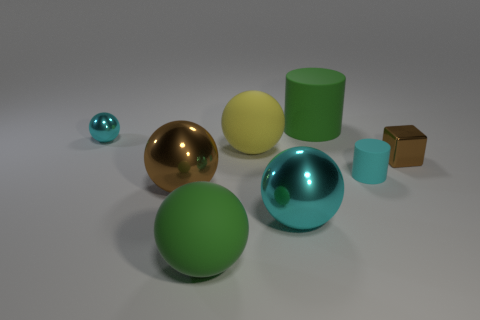Is the color of the tiny ball the same as the small cylinder?
Make the answer very short. Yes. What is the green thing left of the yellow object made of?
Offer a very short reply. Rubber. Are there any big rubber spheres of the same color as the large cylinder?
Provide a short and direct response. Yes. What shape is the cyan object that is the same size as the yellow object?
Your answer should be compact. Sphere. There is a big matte sphere in front of the large yellow ball; what color is it?
Provide a short and direct response. Green. There is a cyan object behind the cube; is there a yellow object to the right of it?
Ensure brevity in your answer.  Yes. How many things are either metal objects that are in front of the metal cube or green objects?
Keep it short and to the point. 4. What material is the object behind the small shiny thing that is to the left of the big brown shiny sphere?
Your answer should be very brief. Rubber. Are there the same number of large things that are behind the tiny shiny block and big matte objects in front of the green rubber ball?
Keep it short and to the point. No. What number of objects are large objects that are on the left side of the large green rubber sphere or brown things left of the tiny brown object?
Provide a succinct answer. 1. 